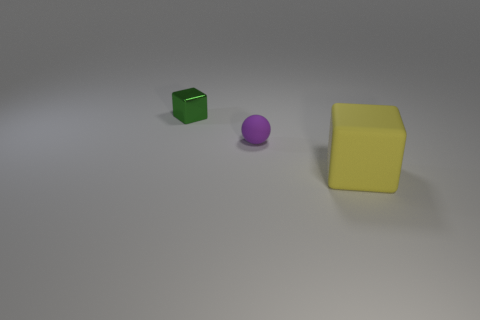Add 2 large purple metal cubes. How many objects exist? 5 Subtract all spheres. How many objects are left? 2 Subtract all small green things. Subtract all tiny matte things. How many objects are left? 1 Add 3 tiny green metallic objects. How many tiny green metallic objects are left? 4 Add 1 big blue cubes. How many big blue cubes exist? 1 Subtract 0 purple cylinders. How many objects are left? 3 